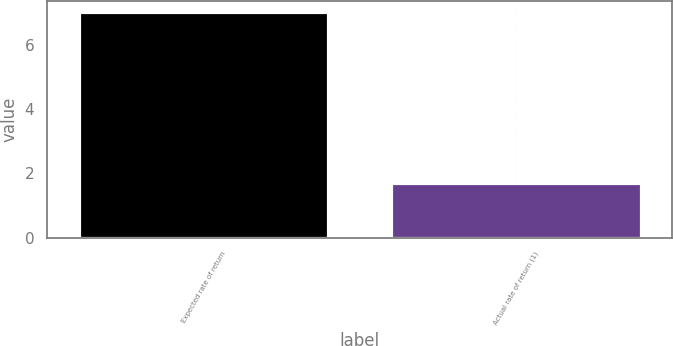<chart> <loc_0><loc_0><loc_500><loc_500><bar_chart><fcel>Expected rate of return<fcel>Actual rate of return (1)<nl><fcel>7<fcel>1.7<nl></chart> 